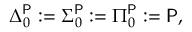<formula> <loc_0><loc_0><loc_500><loc_500>\Delta _ { 0 } ^ { P } \colon = \Sigma _ { 0 } ^ { P } \colon = \Pi _ { 0 } ^ { P } \colon = { P } ,</formula> 